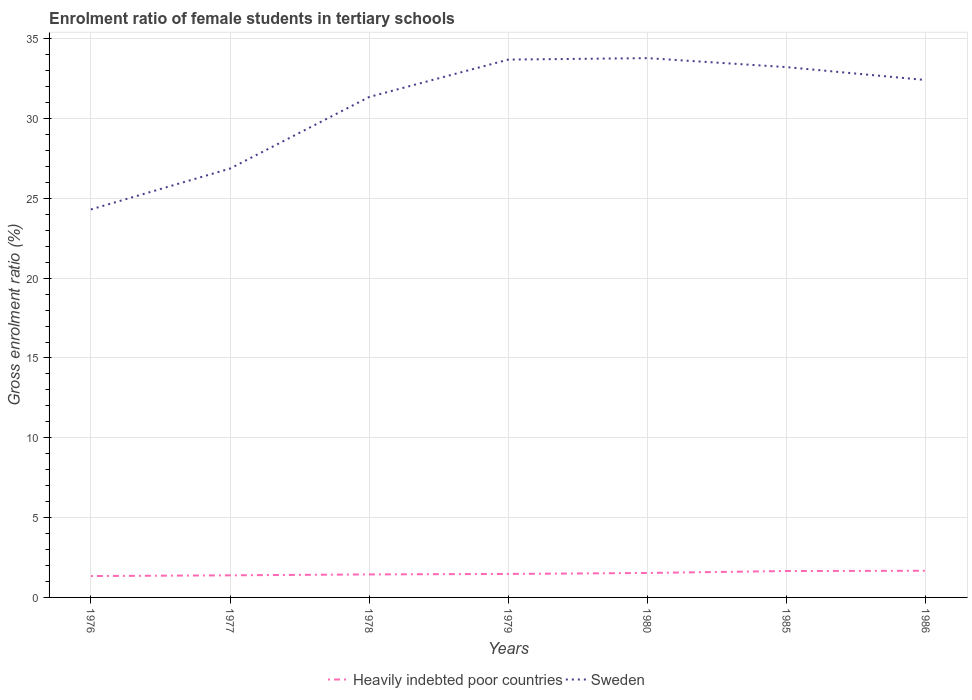Across all years, what is the maximum enrolment ratio of female students in tertiary schools in Heavily indebted poor countries?
Your answer should be very brief. 1.34. In which year was the enrolment ratio of female students in tertiary schools in Sweden maximum?
Provide a succinct answer. 1976. What is the total enrolment ratio of female students in tertiary schools in Heavily indebted poor countries in the graph?
Provide a short and direct response. -0.09. What is the difference between the highest and the second highest enrolment ratio of female students in tertiary schools in Sweden?
Your answer should be compact. 9.48. How many lines are there?
Make the answer very short. 2. How many years are there in the graph?
Your answer should be very brief. 7. What is the difference between two consecutive major ticks on the Y-axis?
Offer a very short reply. 5. Does the graph contain any zero values?
Make the answer very short. No. Does the graph contain grids?
Your answer should be very brief. Yes. How many legend labels are there?
Offer a very short reply. 2. How are the legend labels stacked?
Your answer should be very brief. Horizontal. What is the title of the graph?
Offer a very short reply. Enrolment ratio of female students in tertiary schools. Does "Haiti" appear as one of the legend labels in the graph?
Offer a terse response. No. What is the label or title of the X-axis?
Make the answer very short. Years. What is the label or title of the Y-axis?
Ensure brevity in your answer.  Gross enrolment ratio (%). What is the Gross enrolment ratio (%) of Heavily indebted poor countries in 1976?
Offer a very short reply. 1.34. What is the Gross enrolment ratio (%) of Sweden in 1976?
Your answer should be compact. 24.31. What is the Gross enrolment ratio (%) in Heavily indebted poor countries in 1977?
Provide a short and direct response. 1.38. What is the Gross enrolment ratio (%) in Sweden in 1977?
Offer a very short reply. 26.87. What is the Gross enrolment ratio (%) of Heavily indebted poor countries in 1978?
Offer a terse response. 1.44. What is the Gross enrolment ratio (%) in Sweden in 1978?
Offer a terse response. 31.35. What is the Gross enrolment ratio (%) of Heavily indebted poor countries in 1979?
Offer a terse response. 1.47. What is the Gross enrolment ratio (%) in Sweden in 1979?
Give a very brief answer. 33.7. What is the Gross enrolment ratio (%) in Heavily indebted poor countries in 1980?
Offer a very short reply. 1.53. What is the Gross enrolment ratio (%) of Sweden in 1980?
Offer a terse response. 33.79. What is the Gross enrolment ratio (%) in Heavily indebted poor countries in 1985?
Ensure brevity in your answer.  1.66. What is the Gross enrolment ratio (%) in Sweden in 1985?
Make the answer very short. 33.22. What is the Gross enrolment ratio (%) of Heavily indebted poor countries in 1986?
Ensure brevity in your answer.  1.67. What is the Gross enrolment ratio (%) of Sweden in 1986?
Offer a terse response. 32.41. Across all years, what is the maximum Gross enrolment ratio (%) in Heavily indebted poor countries?
Your answer should be compact. 1.67. Across all years, what is the maximum Gross enrolment ratio (%) in Sweden?
Make the answer very short. 33.79. Across all years, what is the minimum Gross enrolment ratio (%) of Heavily indebted poor countries?
Offer a very short reply. 1.34. Across all years, what is the minimum Gross enrolment ratio (%) in Sweden?
Provide a succinct answer. 24.31. What is the total Gross enrolment ratio (%) in Heavily indebted poor countries in the graph?
Your answer should be very brief. 10.49. What is the total Gross enrolment ratio (%) of Sweden in the graph?
Keep it short and to the point. 215.64. What is the difference between the Gross enrolment ratio (%) in Heavily indebted poor countries in 1976 and that in 1977?
Provide a short and direct response. -0.04. What is the difference between the Gross enrolment ratio (%) of Sweden in 1976 and that in 1977?
Make the answer very short. -2.56. What is the difference between the Gross enrolment ratio (%) of Heavily indebted poor countries in 1976 and that in 1978?
Make the answer very short. -0.1. What is the difference between the Gross enrolment ratio (%) in Sweden in 1976 and that in 1978?
Offer a very short reply. -7.05. What is the difference between the Gross enrolment ratio (%) of Heavily indebted poor countries in 1976 and that in 1979?
Offer a terse response. -0.13. What is the difference between the Gross enrolment ratio (%) in Sweden in 1976 and that in 1979?
Offer a terse response. -9.39. What is the difference between the Gross enrolment ratio (%) of Heavily indebted poor countries in 1976 and that in 1980?
Ensure brevity in your answer.  -0.19. What is the difference between the Gross enrolment ratio (%) of Sweden in 1976 and that in 1980?
Give a very brief answer. -9.48. What is the difference between the Gross enrolment ratio (%) in Heavily indebted poor countries in 1976 and that in 1985?
Offer a very short reply. -0.32. What is the difference between the Gross enrolment ratio (%) in Sweden in 1976 and that in 1985?
Make the answer very short. -8.92. What is the difference between the Gross enrolment ratio (%) of Heavily indebted poor countries in 1976 and that in 1986?
Your answer should be compact. -0.33. What is the difference between the Gross enrolment ratio (%) in Sweden in 1976 and that in 1986?
Ensure brevity in your answer.  -8.11. What is the difference between the Gross enrolment ratio (%) of Heavily indebted poor countries in 1977 and that in 1978?
Provide a short and direct response. -0.06. What is the difference between the Gross enrolment ratio (%) of Sweden in 1977 and that in 1978?
Your response must be concise. -4.49. What is the difference between the Gross enrolment ratio (%) of Heavily indebted poor countries in 1977 and that in 1979?
Provide a short and direct response. -0.09. What is the difference between the Gross enrolment ratio (%) in Sweden in 1977 and that in 1979?
Offer a very short reply. -6.83. What is the difference between the Gross enrolment ratio (%) in Heavily indebted poor countries in 1977 and that in 1980?
Give a very brief answer. -0.15. What is the difference between the Gross enrolment ratio (%) of Sweden in 1977 and that in 1980?
Give a very brief answer. -6.92. What is the difference between the Gross enrolment ratio (%) in Heavily indebted poor countries in 1977 and that in 1985?
Give a very brief answer. -0.27. What is the difference between the Gross enrolment ratio (%) of Sweden in 1977 and that in 1985?
Ensure brevity in your answer.  -6.36. What is the difference between the Gross enrolment ratio (%) of Heavily indebted poor countries in 1977 and that in 1986?
Your response must be concise. -0.29. What is the difference between the Gross enrolment ratio (%) in Sweden in 1977 and that in 1986?
Provide a succinct answer. -5.55. What is the difference between the Gross enrolment ratio (%) in Heavily indebted poor countries in 1978 and that in 1979?
Provide a succinct answer. -0.03. What is the difference between the Gross enrolment ratio (%) of Sweden in 1978 and that in 1979?
Provide a succinct answer. -2.34. What is the difference between the Gross enrolment ratio (%) in Heavily indebted poor countries in 1978 and that in 1980?
Provide a succinct answer. -0.09. What is the difference between the Gross enrolment ratio (%) of Sweden in 1978 and that in 1980?
Ensure brevity in your answer.  -2.43. What is the difference between the Gross enrolment ratio (%) in Heavily indebted poor countries in 1978 and that in 1985?
Offer a very short reply. -0.21. What is the difference between the Gross enrolment ratio (%) of Sweden in 1978 and that in 1985?
Provide a short and direct response. -1.87. What is the difference between the Gross enrolment ratio (%) of Heavily indebted poor countries in 1978 and that in 1986?
Offer a very short reply. -0.23. What is the difference between the Gross enrolment ratio (%) of Sweden in 1978 and that in 1986?
Offer a very short reply. -1.06. What is the difference between the Gross enrolment ratio (%) in Heavily indebted poor countries in 1979 and that in 1980?
Offer a very short reply. -0.06. What is the difference between the Gross enrolment ratio (%) in Sweden in 1979 and that in 1980?
Provide a short and direct response. -0.09. What is the difference between the Gross enrolment ratio (%) of Heavily indebted poor countries in 1979 and that in 1985?
Offer a very short reply. -0.18. What is the difference between the Gross enrolment ratio (%) in Sweden in 1979 and that in 1985?
Provide a succinct answer. 0.47. What is the difference between the Gross enrolment ratio (%) of Heavily indebted poor countries in 1979 and that in 1986?
Provide a succinct answer. -0.2. What is the difference between the Gross enrolment ratio (%) of Sweden in 1979 and that in 1986?
Make the answer very short. 1.28. What is the difference between the Gross enrolment ratio (%) in Heavily indebted poor countries in 1980 and that in 1985?
Offer a terse response. -0.12. What is the difference between the Gross enrolment ratio (%) in Sweden in 1980 and that in 1985?
Ensure brevity in your answer.  0.56. What is the difference between the Gross enrolment ratio (%) of Heavily indebted poor countries in 1980 and that in 1986?
Give a very brief answer. -0.14. What is the difference between the Gross enrolment ratio (%) in Sweden in 1980 and that in 1986?
Your response must be concise. 1.37. What is the difference between the Gross enrolment ratio (%) of Heavily indebted poor countries in 1985 and that in 1986?
Make the answer very short. -0.01. What is the difference between the Gross enrolment ratio (%) of Sweden in 1985 and that in 1986?
Make the answer very short. 0.81. What is the difference between the Gross enrolment ratio (%) of Heavily indebted poor countries in 1976 and the Gross enrolment ratio (%) of Sweden in 1977?
Offer a very short reply. -25.53. What is the difference between the Gross enrolment ratio (%) of Heavily indebted poor countries in 1976 and the Gross enrolment ratio (%) of Sweden in 1978?
Offer a very short reply. -30.01. What is the difference between the Gross enrolment ratio (%) of Heavily indebted poor countries in 1976 and the Gross enrolment ratio (%) of Sweden in 1979?
Your response must be concise. -32.36. What is the difference between the Gross enrolment ratio (%) of Heavily indebted poor countries in 1976 and the Gross enrolment ratio (%) of Sweden in 1980?
Your answer should be very brief. -32.45. What is the difference between the Gross enrolment ratio (%) in Heavily indebted poor countries in 1976 and the Gross enrolment ratio (%) in Sweden in 1985?
Keep it short and to the point. -31.88. What is the difference between the Gross enrolment ratio (%) in Heavily indebted poor countries in 1976 and the Gross enrolment ratio (%) in Sweden in 1986?
Ensure brevity in your answer.  -31.07. What is the difference between the Gross enrolment ratio (%) of Heavily indebted poor countries in 1977 and the Gross enrolment ratio (%) of Sweden in 1978?
Ensure brevity in your answer.  -29.97. What is the difference between the Gross enrolment ratio (%) of Heavily indebted poor countries in 1977 and the Gross enrolment ratio (%) of Sweden in 1979?
Make the answer very short. -32.31. What is the difference between the Gross enrolment ratio (%) of Heavily indebted poor countries in 1977 and the Gross enrolment ratio (%) of Sweden in 1980?
Offer a very short reply. -32.4. What is the difference between the Gross enrolment ratio (%) in Heavily indebted poor countries in 1977 and the Gross enrolment ratio (%) in Sweden in 1985?
Keep it short and to the point. -31.84. What is the difference between the Gross enrolment ratio (%) of Heavily indebted poor countries in 1977 and the Gross enrolment ratio (%) of Sweden in 1986?
Offer a terse response. -31.03. What is the difference between the Gross enrolment ratio (%) of Heavily indebted poor countries in 1978 and the Gross enrolment ratio (%) of Sweden in 1979?
Make the answer very short. -32.25. What is the difference between the Gross enrolment ratio (%) of Heavily indebted poor countries in 1978 and the Gross enrolment ratio (%) of Sweden in 1980?
Ensure brevity in your answer.  -32.34. What is the difference between the Gross enrolment ratio (%) of Heavily indebted poor countries in 1978 and the Gross enrolment ratio (%) of Sweden in 1985?
Ensure brevity in your answer.  -31.78. What is the difference between the Gross enrolment ratio (%) of Heavily indebted poor countries in 1978 and the Gross enrolment ratio (%) of Sweden in 1986?
Your answer should be very brief. -30.97. What is the difference between the Gross enrolment ratio (%) in Heavily indebted poor countries in 1979 and the Gross enrolment ratio (%) in Sweden in 1980?
Ensure brevity in your answer.  -32.31. What is the difference between the Gross enrolment ratio (%) of Heavily indebted poor countries in 1979 and the Gross enrolment ratio (%) of Sweden in 1985?
Your answer should be very brief. -31.75. What is the difference between the Gross enrolment ratio (%) of Heavily indebted poor countries in 1979 and the Gross enrolment ratio (%) of Sweden in 1986?
Give a very brief answer. -30.94. What is the difference between the Gross enrolment ratio (%) in Heavily indebted poor countries in 1980 and the Gross enrolment ratio (%) in Sweden in 1985?
Give a very brief answer. -31.69. What is the difference between the Gross enrolment ratio (%) in Heavily indebted poor countries in 1980 and the Gross enrolment ratio (%) in Sweden in 1986?
Ensure brevity in your answer.  -30.88. What is the difference between the Gross enrolment ratio (%) in Heavily indebted poor countries in 1985 and the Gross enrolment ratio (%) in Sweden in 1986?
Give a very brief answer. -30.76. What is the average Gross enrolment ratio (%) of Heavily indebted poor countries per year?
Offer a terse response. 1.5. What is the average Gross enrolment ratio (%) in Sweden per year?
Your answer should be very brief. 30.81. In the year 1976, what is the difference between the Gross enrolment ratio (%) of Heavily indebted poor countries and Gross enrolment ratio (%) of Sweden?
Give a very brief answer. -22.97. In the year 1977, what is the difference between the Gross enrolment ratio (%) in Heavily indebted poor countries and Gross enrolment ratio (%) in Sweden?
Your response must be concise. -25.48. In the year 1978, what is the difference between the Gross enrolment ratio (%) in Heavily indebted poor countries and Gross enrolment ratio (%) in Sweden?
Provide a short and direct response. -29.91. In the year 1979, what is the difference between the Gross enrolment ratio (%) of Heavily indebted poor countries and Gross enrolment ratio (%) of Sweden?
Offer a terse response. -32.22. In the year 1980, what is the difference between the Gross enrolment ratio (%) in Heavily indebted poor countries and Gross enrolment ratio (%) in Sweden?
Ensure brevity in your answer.  -32.25. In the year 1985, what is the difference between the Gross enrolment ratio (%) in Heavily indebted poor countries and Gross enrolment ratio (%) in Sweden?
Provide a succinct answer. -31.57. In the year 1986, what is the difference between the Gross enrolment ratio (%) in Heavily indebted poor countries and Gross enrolment ratio (%) in Sweden?
Your answer should be very brief. -30.74. What is the ratio of the Gross enrolment ratio (%) of Heavily indebted poor countries in 1976 to that in 1977?
Offer a terse response. 0.97. What is the ratio of the Gross enrolment ratio (%) of Sweden in 1976 to that in 1977?
Your response must be concise. 0.9. What is the ratio of the Gross enrolment ratio (%) in Heavily indebted poor countries in 1976 to that in 1978?
Ensure brevity in your answer.  0.93. What is the ratio of the Gross enrolment ratio (%) of Sweden in 1976 to that in 1978?
Keep it short and to the point. 0.78. What is the ratio of the Gross enrolment ratio (%) in Heavily indebted poor countries in 1976 to that in 1979?
Offer a very short reply. 0.91. What is the ratio of the Gross enrolment ratio (%) in Sweden in 1976 to that in 1979?
Give a very brief answer. 0.72. What is the ratio of the Gross enrolment ratio (%) in Heavily indebted poor countries in 1976 to that in 1980?
Make the answer very short. 0.87. What is the ratio of the Gross enrolment ratio (%) of Sweden in 1976 to that in 1980?
Your response must be concise. 0.72. What is the ratio of the Gross enrolment ratio (%) in Heavily indebted poor countries in 1976 to that in 1985?
Your response must be concise. 0.81. What is the ratio of the Gross enrolment ratio (%) of Sweden in 1976 to that in 1985?
Provide a succinct answer. 0.73. What is the ratio of the Gross enrolment ratio (%) of Heavily indebted poor countries in 1976 to that in 1986?
Provide a succinct answer. 0.8. What is the ratio of the Gross enrolment ratio (%) of Sweden in 1976 to that in 1986?
Provide a succinct answer. 0.75. What is the ratio of the Gross enrolment ratio (%) of Heavily indebted poor countries in 1977 to that in 1978?
Offer a terse response. 0.96. What is the ratio of the Gross enrolment ratio (%) in Sweden in 1977 to that in 1978?
Your answer should be very brief. 0.86. What is the ratio of the Gross enrolment ratio (%) of Heavily indebted poor countries in 1977 to that in 1979?
Provide a short and direct response. 0.94. What is the ratio of the Gross enrolment ratio (%) of Sweden in 1977 to that in 1979?
Provide a short and direct response. 0.8. What is the ratio of the Gross enrolment ratio (%) of Heavily indebted poor countries in 1977 to that in 1980?
Provide a short and direct response. 0.9. What is the ratio of the Gross enrolment ratio (%) of Sweden in 1977 to that in 1980?
Your answer should be compact. 0.8. What is the ratio of the Gross enrolment ratio (%) of Heavily indebted poor countries in 1977 to that in 1985?
Offer a terse response. 0.84. What is the ratio of the Gross enrolment ratio (%) in Sweden in 1977 to that in 1985?
Offer a terse response. 0.81. What is the ratio of the Gross enrolment ratio (%) in Heavily indebted poor countries in 1977 to that in 1986?
Provide a short and direct response. 0.83. What is the ratio of the Gross enrolment ratio (%) of Sweden in 1977 to that in 1986?
Provide a succinct answer. 0.83. What is the ratio of the Gross enrolment ratio (%) of Heavily indebted poor countries in 1978 to that in 1979?
Ensure brevity in your answer.  0.98. What is the ratio of the Gross enrolment ratio (%) in Sweden in 1978 to that in 1979?
Make the answer very short. 0.93. What is the ratio of the Gross enrolment ratio (%) in Heavily indebted poor countries in 1978 to that in 1980?
Ensure brevity in your answer.  0.94. What is the ratio of the Gross enrolment ratio (%) of Sweden in 1978 to that in 1980?
Your response must be concise. 0.93. What is the ratio of the Gross enrolment ratio (%) of Heavily indebted poor countries in 1978 to that in 1985?
Your answer should be compact. 0.87. What is the ratio of the Gross enrolment ratio (%) of Sweden in 1978 to that in 1985?
Give a very brief answer. 0.94. What is the ratio of the Gross enrolment ratio (%) in Heavily indebted poor countries in 1978 to that in 1986?
Provide a short and direct response. 0.86. What is the ratio of the Gross enrolment ratio (%) of Sweden in 1978 to that in 1986?
Make the answer very short. 0.97. What is the ratio of the Gross enrolment ratio (%) of Heavily indebted poor countries in 1979 to that in 1980?
Your response must be concise. 0.96. What is the ratio of the Gross enrolment ratio (%) in Heavily indebted poor countries in 1979 to that in 1985?
Ensure brevity in your answer.  0.89. What is the ratio of the Gross enrolment ratio (%) of Sweden in 1979 to that in 1985?
Provide a succinct answer. 1.01. What is the ratio of the Gross enrolment ratio (%) in Heavily indebted poor countries in 1979 to that in 1986?
Provide a short and direct response. 0.88. What is the ratio of the Gross enrolment ratio (%) of Sweden in 1979 to that in 1986?
Provide a short and direct response. 1.04. What is the ratio of the Gross enrolment ratio (%) in Heavily indebted poor countries in 1980 to that in 1985?
Your response must be concise. 0.93. What is the ratio of the Gross enrolment ratio (%) in Sweden in 1980 to that in 1985?
Your response must be concise. 1.02. What is the ratio of the Gross enrolment ratio (%) in Heavily indebted poor countries in 1980 to that in 1986?
Make the answer very short. 0.92. What is the ratio of the Gross enrolment ratio (%) of Sweden in 1980 to that in 1986?
Ensure brevity in your answer.  1.04. What is the ratio of the Gross enrolment ratio (%) of Sweden in 1985 to that in 1986?
Your answer should be very brief. 1.02. What is the difference between the highest and the second highest Gross enrolment ratio (%) of Heavily indebted poor countries?
Your response must be concise. 0.01. What is the difference between the highest and the second highest Gross enrolment ratio (%) in Sweden?
Ensure brevity in your answer.  0.09. What is the difference between the highest and the lowest Gross enrolment ratio (%) in Heavily indebted poor countries?
Give a very brief answer. 0.33. What is the difference between the highest and the lowest Gross enrolment ratio (%) of Sweden?
Provide a succinct answer. 9.48. 